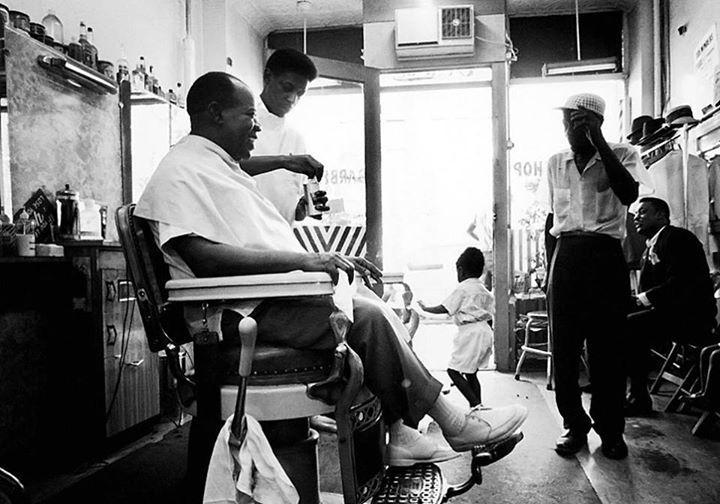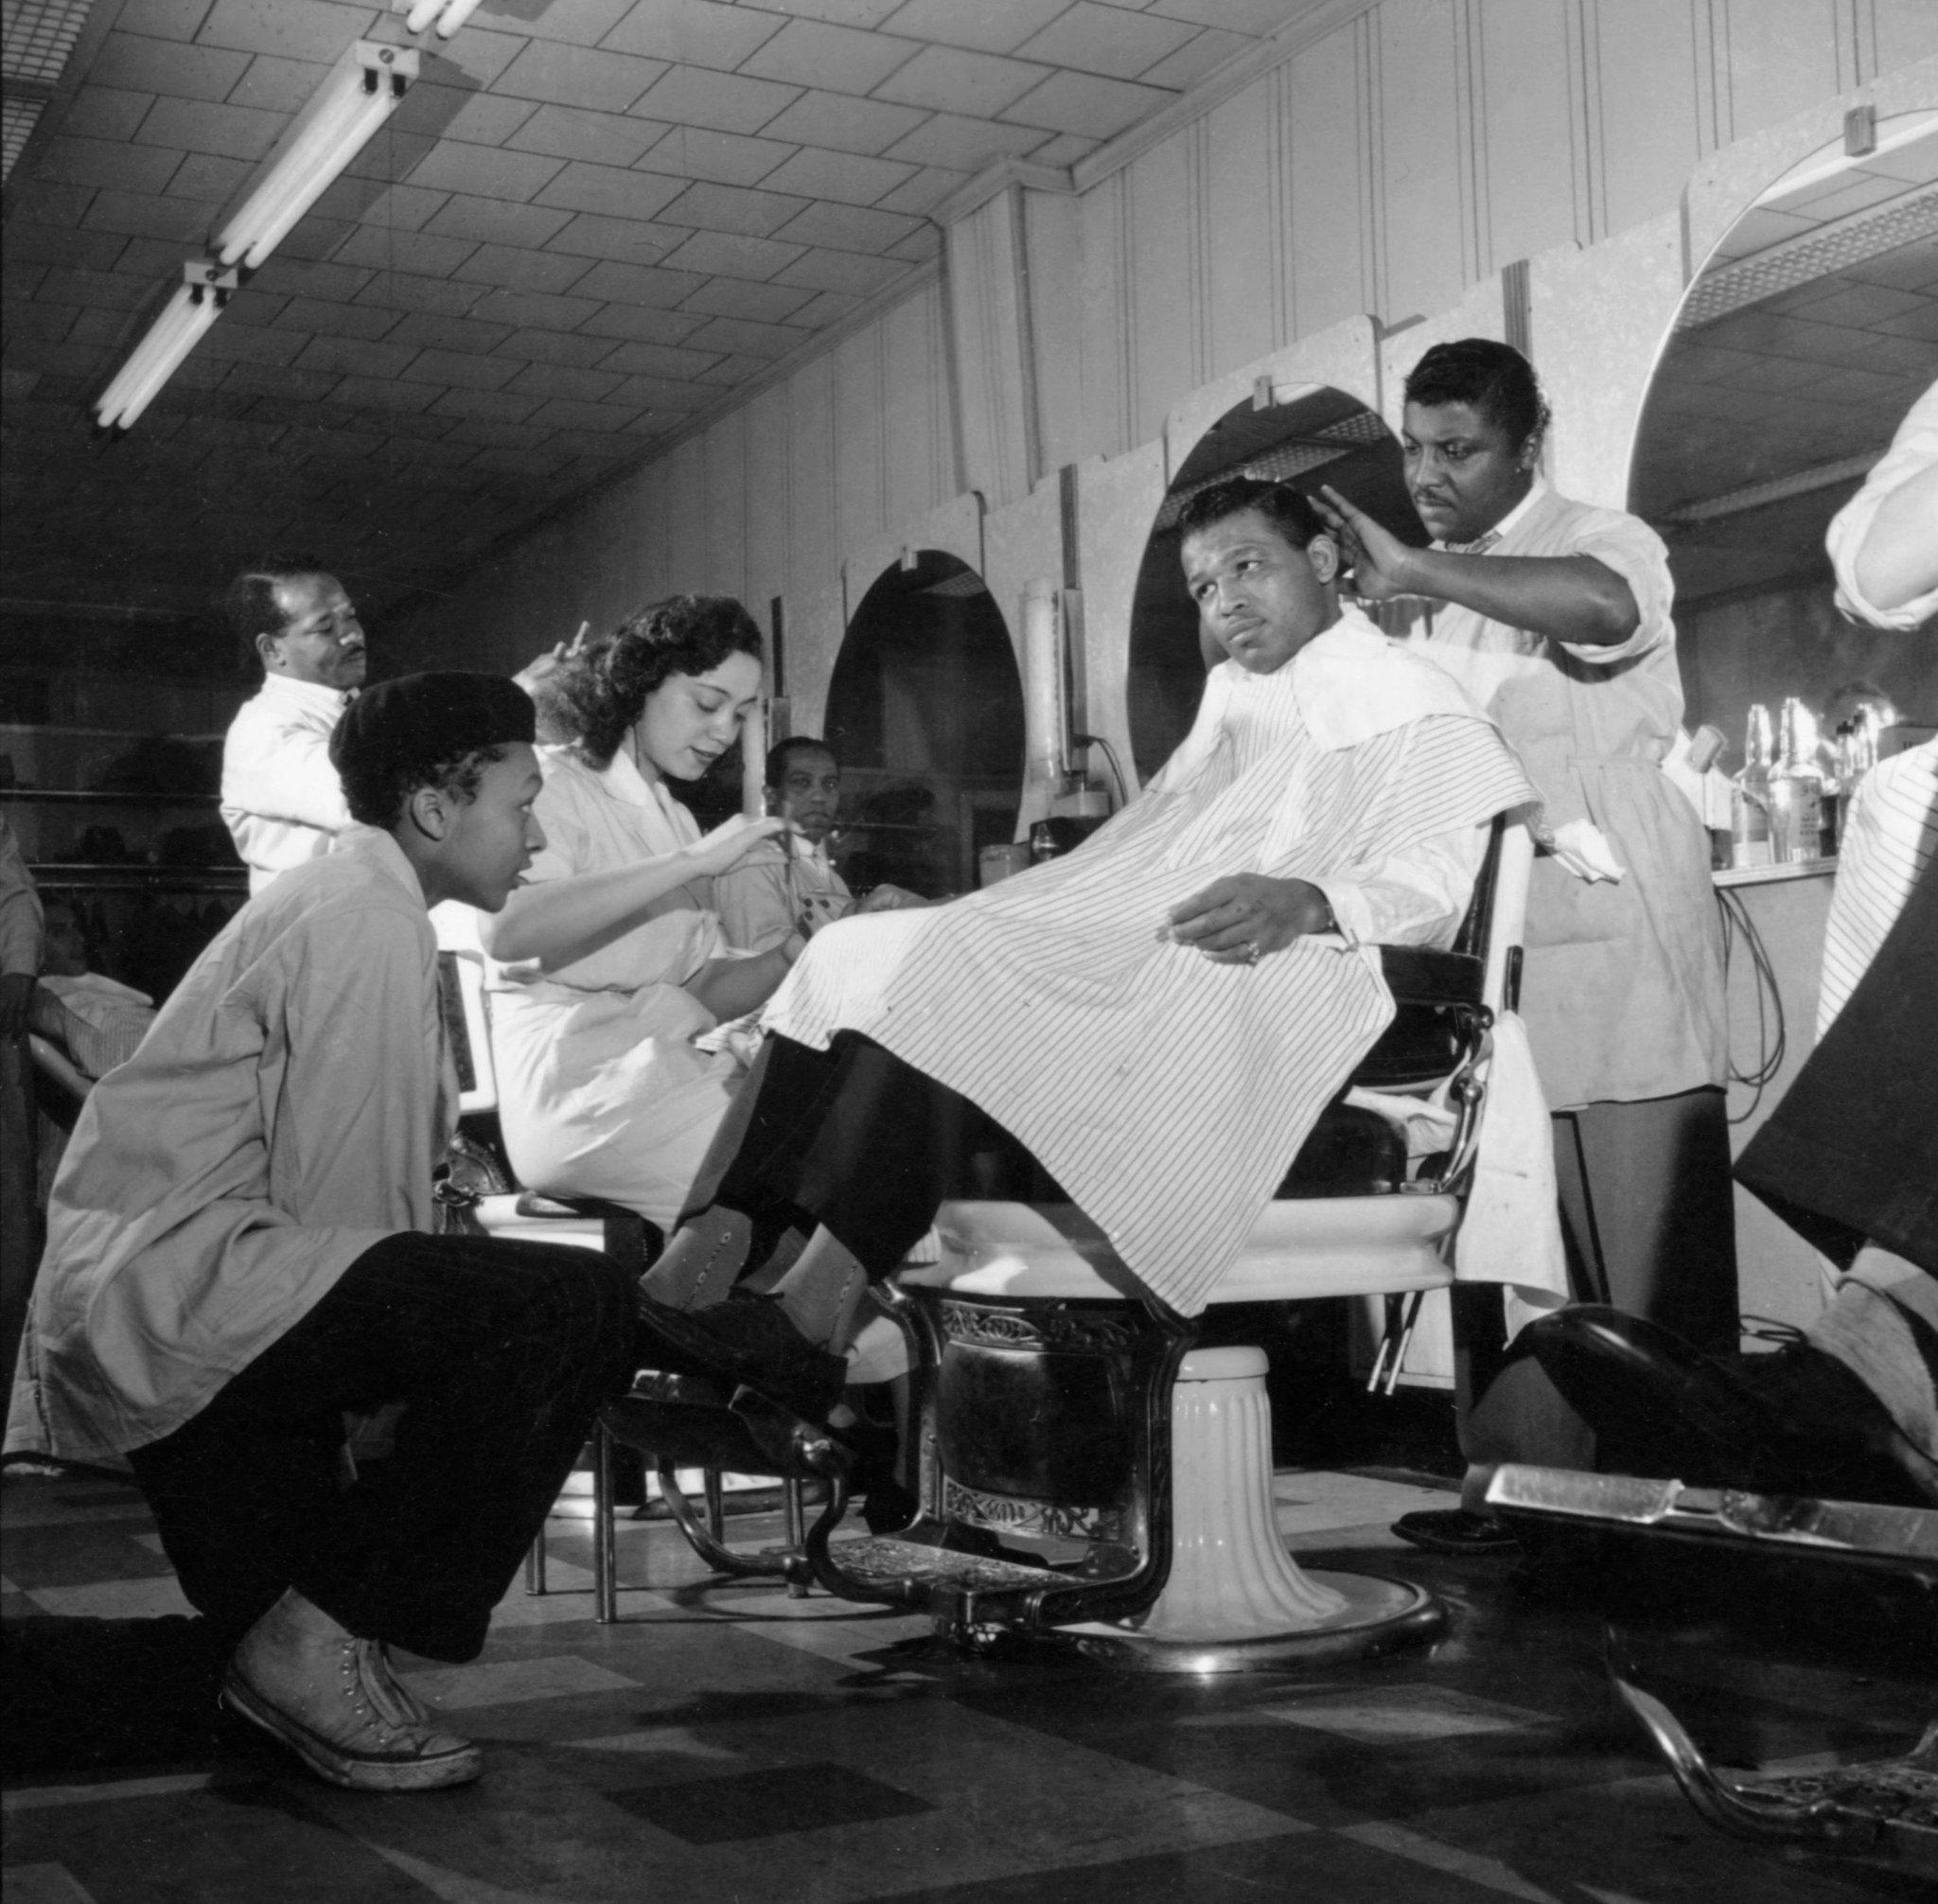The first image is the image on the left, the second image is the image on the right. Assess this claim about the two images: "An image shows a display of barber tools, including scissors.". Correct or not? Answer yes or no. No. The first image is the image on the left, the second image is the image on the right. For the images displayed, is the sentence "A barbershop image shows a man sitting in a barber chair with other people in the shop, and large windows in the background." factually correct? Answer yes or no. Yes. 